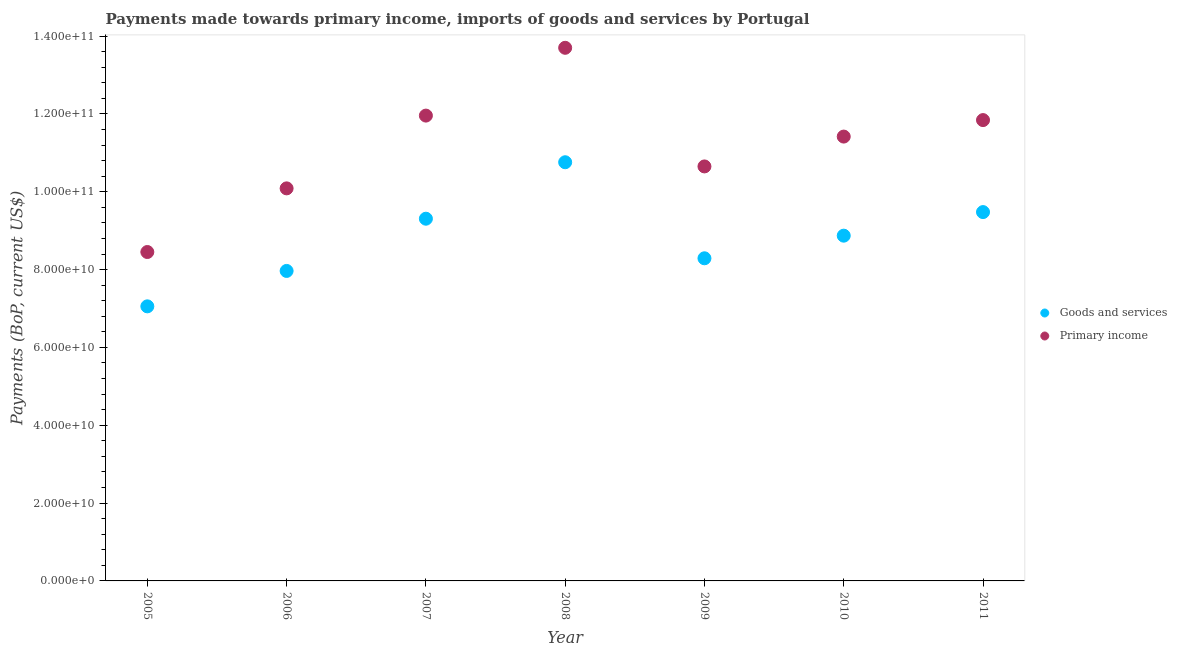What is the payments made towards primary income in 2005?
Provide a succinct answer. 8.45e+1. Across all years, what is the maximum payments made towards goods and services?
Your answer should be very brief. 1.08e+11. Across all years, what is the minimum payments made towards goods and services?
Offer a very short reply. 7.05e+1. In which year was the payments made towards goods and services maximum?
Provide a short and direct response. 2008. In which year was the payments made towards primary income minimum?
Keep it short and to the point. 2005. What is the total payments made towards primary income in the graph?
Offer a terse response. 7.81e+11. What is the difference between the payments made towards primary income in 2005 and that in 2009?
Ensure brevity in your answer.  -2.20e+1. What is the difference between the payments made towards primary income in 2007 and the payments made towards goods and services in 2009?
Your answer should be compact. 3.67e+1. What is the average payments made towards primary income per year?
Offer a very short reply. 1.12e+11. In the year 2010, what is the difference between the payments made towards primary income and payments made towards goods and services?
Give a very brief answer. 2.55e+1. In how many years, is the payments made towards goods and services greater than 128000000000 US$?
Your answer should be very brief. 0. What is the ratio of the payments made towards goods and services in 2009 to that in 2010?
Offer a very short reply. 0.93. Is the payments made towards goods and services in 2007 less than that in 2009?
Make the answer very short. No. Is the difference between the payments made towards goods and services in 2006 and 2008 greater than the difference between the payments made towards primary income in 2006 and 2008?
Ensure brevity in your answer.  Yes. What is the difference between the highest and the second highest payments made towards primary income?
Provide a short and direct response. 1.74e+1. What is the difference between the highest and the lowest payments made towards goods and services?
Make the answer very short. 3.70e+1. Is the sum of the payments made towards goods and services in 2010 and 2011 greater than the maximum payments made towards primary income across all years?
Ensure brevity in your answer.  Yes. Does the payments made towards primary income monotonically increase over the years?
Give a very brief answer. No. Is the payments made towards goods and services strictly greater than the payments made towards primary income over the years?
Your response must be concise. No. How many dotlines are there?
Provide a short and direct response. 2. Are the values on the major ticks of Y-axis written in scientific E-notation?
Ensure brevity in your answer.  Yes. Does the graph contain grids?
Ensure brevity in your answer.  No. How many legend labels are there?
Ensure brevity in your answer.  2. What is the title of the graph?
Your answer should be compact. Payments made towards primary income, imports of goods and services by Portugal. What is the label or title of the Y-axis?
Your response must be concise. Payments (BoP, current US$). What is the Payments (BoP, current US$) in Goods and services in 2005?
Make the answer very short. 7.05e+1. What is the Payments (BoP, current US$) of Primary income in 2005?
Ensure brevity in your answer.  8.45e+1. What is the Payments (BoP, current US$) of Goods and services in 2006?
Your response must be concise. 7.96e+1. What is the Payments (BoP, current US$) of Primary income in 2006?
Your response must be concise. 1.01e+11. What is the Payments (BoP, current US$) in Goods and services in 2007?
Provide a succinct answer. 9.31e+1. What is the Payments (BoP, current US$) in Primary income in 2007?
Offer a very short reply. 1.20e+11. What is the Payments (BoP, current US$) in Goods and services in 2008?
Your answer should be compact. 1.08e+11. What is the Payments (BoP, current US$) in Primary income in 2008?
Your answer should be very brief. 1.37e+11. What is the Payments (BoP, current US$) in Goods and services in 2009?
Keep it short and to the point. 8.29e+1. What is the Payments (BoP, current US$) of Primary income in 2009?
Ensure brevity in your answer.  1.07e+11. What is the Payments (BoP, current US$) in Goods and services in 2010?
Offer a terse response. 8.87e+1. What is the Payments (BoP, current US$) in Primary income in 2010?
Give a very brief answer. 1.14e+11. What is the Payments (BoP, current US$) of Goods and services in 2011?
Your answer should be very brief. 9.48e+1. What is the Payments (BoP, current US$) in Primary income in 2011?
Make the answer very short. 1.18e+11. Across all years, what is the maximum Payments (BoP, current US$) in Goods and services?
Ensure brevity in your answer.  1.08e+11. Across all years, what is the maximum Payments (BoP, current US$) in Primary income?
Keep it short and to the point. 1.37e+11. Across all years, what is the minimum Payments (BoP, current US$) of Goods and services?
Make the answer very short. 7.05e+1. Across all years, what is the minimum Payments (BoP, current US$) in Primary income?
Give a very brief answer. 8.45e+1. What is the total Payments (BoP, current US$) of Goods and services in the graph?
Offer a terse response. 6.17e+11. What is the total Payments (BoP, current US$) of Primary income in the graph?
Give a very brief answer. 7.81e+11. What is the difference between the Payments (BoP, current US$) in Goods and services in 2005 and that in 2006?
Make the answer very short. -9.10e+09. What is the difference between the Payments (BoP, current US$) of Primary income in 2005 and that in 2006?
Keep it short and to the point. -1.64e+1. What is the difference between the Payments (BoP, current US$) of Goods and services in 2005 and that in 2007?
Offer a terse response. -2.25e+1. What is the difference between the Payments (BoP, current US$) of Primary income in 2005 and that in 2007?
Provide a succinct answer. -3.50e+1. What is the difference between the Payments (BoP, current US$) of Goods and services in 2005 and that in 2008?
Make the answer very short. -3.70e+1. What is the difference between the Payments (BoP, current US$) in Primary income in 2005 and that in 2008?
Offer a terse response. -5.25e+1. What is the difference between the Payments (BoP, current US$) in Goods and services in 2005 and that in 2009?
Provide a short and direct response. -1.23e+1. What is the difference between the Payments (BoP, current US$) of Primary income in 2005 and that in 2009?
Your answer should be compact. -2.20e+1. What is the difference between the Payments (BoP, current US$) in Goods and services in 2005 and that in 2010?
Offer a very short reply. -1.82e+1. What is the difference between the Payments (BoP, current US$) in Primary income in 2005 and that in 2010?
Keep it short and to the point. -2.97e+1. What is the difference between the Payments (BoP, current US$) of Goods and services in 2005 and that in 2011?
Provide a succinct answer. -2.42e+1. What is the difference between the Payments (BoP, current US$) in Primary income in 2005 and that in 2011?
Give a very brief answer. -3.39e+1. What is the difference between the Payments (BoP, current US$) of Goods and services in 2006 and that in 2007?
Ensure brevity in your answer.  -1.34e+1. What is the difference between the Payments (BoP, current US$) in Primary income in 2006 and that in 2007?
Offer a terse response. -1.87e+1. What is the difference between the Payments (BoP, current US$) in Goods and services in 2006 and that in 2008?
Provide a short and direct response. -2.79e+1. What is the difference between the Payments (BoP, current US$) of Primary income in 2006 and that in 2008?
Your answer should be very brief. -3.61e+1. What is the difference between the Payments (BoP, current US$) of Goods and services in 2006 and that in 2009?
Provide a succinct answer. -3.25e+09. What is the difference between the Payments (BoP, current US$) in Primary income in 2006 and that in 2009?
Provide a succinct answer. -5.64e+09. What is the difference between the Payments (BoP, current US$) in Goods and services in 2006 and that in 2010?
Provide a succinct answer. -9.06e+09. What is the difference between the Payments (BoP, current US$) in Primary income in 2006 and that in 2010?
Make the answer very short. -1.33e+1. What is the difference between the Payments (BoP, current US$) of Goods and services in 2006 and that in 2011?
Ensure brevity in your answer.  -1.51e+1. What is the difference between the Payments (BoP, current US$) in Primary income in 2006 and that in 2011?
Make the answer very short. -1.75e+1. What is the difference between the Payments (BoP, current US$) of Goods and services in 2007 and that in 2008?
Offer a very short reply. -1.45e+1. What is the difference between the Payments (BoP, current US$) in Primary income in 2007 and that in 2008?
Your answer should be compact. -1.74e+1. What is the difference between the Payments (BoP, current US$) of Goods and services in 2007 and that in 2009?
Offer a very short reply. 1.02e+1. What is the difference between the Payments (BoP, current US$) of Primary income in 2007 and that in 2009?
Your answer should be very brief. 1.31e+1. What is the difference between the Payments (BoP, current US$) in Goods and services in 2007 and that in 2010?
Your response must be concise. 4.36e+09. What is the difference between the Payments (BoP, current US$) in Primary income in 2007 and that in 2010?
Offer a very short reply. 5.39e+09. What is the difference between the Payments (BoP, current US$) of Goods and services in 2007 and that in 2011?
Provide a succinct answer. -1.70e+09. What is the difference between the Payments (BoP, current US$) of Primary income in 2007 and that in 2011?
Offer a terse response. 1.15e+09. What is the difference between the Payments (BoP, current US$) in Goods and services in 2008 and that in 2009?
Your answer should be compact. 2.47e+1. What is the difference between the Payments (BoP, current US$) of Primary income in 2008 and that in 2009?
Offer a very short reply. 3.05e+1. What is the difference between the Payments (BoP, current US$) of Goods and services in 2008 and that in 2010?
Your response must be concise. 1.89e+1. What is the difference between the Payments (BoP, current US$) in Primary income in 2008 and that in 2010?
Offer a very short reply. 2.28e+1. What is the difference between the Payments (BoP, current US$) in Goods and services in 2008 and that in 2011?
Ensure brevity in your answer.  1.28e+1. What is the difference between the Payments (BoP, current US$) of Primary income in 2008 and that in 2011?
Offer a terse response. 1.86e+1. What is the difference between the Payments (BoP, current US$) of Goods and services in 2009 and that in 2010?
Your answer should be very brief. -5.81e+09. What is the difference between the Payments (BoP, current US$) of Primary income in 2009 and that in 2010?
Your response must be concise. -7.67e+09. What is the difference between the Payments (BoP, current US$) in Goods and services in 2009 and that in 2011?
Your answer should be very brief. -1.19e+1. What is the difference between the Payments (BoP, current US$) in Primary income in 2009 and that in 2011?
Keep it short and to the point. -1.19e+1. What is the difference between the Payments (BoP, current US$) in Goods and services in 2010 and that in 2011?
Give a very brief answer. -6.06e+09. What is the difference between the Payments (BoP, current US$) of Primary income in 2010 and that in 2011?
Your response must be concise. -4.24e+09. What is the difference between the Payments (BoP, current US$) in Goods and services in 2005 and the Payments (BoP, current US$) in Primary income in 2006?
Give a very brief answer. -3.03e+1. What is the difference between the Payments (BoP, current US$) of Goods and services in 2005 and the Payments (BoP, current US$) of Primary income in 2007?
Keep it short and to the point. -4.90e+1. What is the difference between the Payments (BoP, current US$) in Goods and services in 2005 and the Payments (BoP, current US$) in Primary income in 2008?
Give a very brief answer. -6.64e+1. What is the difference between the Payments (BoP, current US$) of Goods and services in 2005 and the Payments (BoP, current US$) of Primary income in 2009?
Your answer should be compact. -3.60e+1. What is the difference between the Payments (BoP, current US$) of Goods and services in 2005 and the Payments (BoP, current US$) of Primary income in 2010?
Ensure brevity in your answer.  -4.36e+1. What is the difference between the Payments (BoP, current US$) of Goods and services in 2005 and the Payments (BoP, current US$) of Primary income in 2011?
Offer a very short reply. -4.79e+1. What is the difference between the Payments (BoP, current US$) of Goods and services in 2006 and the Payments (BoP, current US$) of Primary income in 2007?
Offer a very short reply. -3.99e+1. What is the difference between the Payments (BoP, current US$) of Goods and services in 2006 and the Payments (BoP, current US$) of Primary income in 2008?
Your answer should be compact. -5.73e+1. What is the difference between the Payments (BoP, current US$) of Goods and services in 2006 and the Payments (BoP, current US$) of Primary income in 2009?
Your answer should be very brief. -2.69e+1. What is the difference between the Payments (BoP, current US$) of Goods and services in 2006 and the Payments (BoP, current US$) of Primary income in 2010?
Make the answer very short. -3.45e+1. What is the difference between the Payments (BoP, current US$) of Goods and services in 2006 and the Payments (BoP, current US$) of Primary income in 2011?
Your answer should be very brief. -3.88e+1. What is the difference between the Payments (BoP, current US$) of Goods and services in 2007 and the Payments (BoP, current US$) of Primary income in 2008?
Your response must be concise. -4.39e+1. What is the difference between the Payments (BoP, current US$) of Goods and services in 2007 and the Payments (BoP, current US$) of Primary income in 2009?
Your response must be concise. -1.34e+1. What is the difference between the Payments (BoP, current US$) of Goods and services in 2007 and the Payments (BoP, current US$) of Primary income in 2010?
Provide a short and direct response. -2.11e+1. What is the difference between the Payments (BoP, current US$) of Goods and services in 2007 and the Payments (BoP, current US$) of Primary income in 2011?
Keep it short and to the point. -2.53e+1. What is the difference between the Payments (BoP, current US$) in Goods and services in 2008 and the Payments (BoP, current US$) in Primary income in 2009?
Your answer should be very brief. 1.07e+09. What is the difference between the Payments (BoP, current US$) in Goods and services in 2008 and the Payments (BoP, current US$) in Primary income in 2010?
Provide a succinct answer. -6.60e+09. What is the difference between the Payments (BoP, current US$) in Goods and services in 2008 and the Payments (BoP, current US$) in Primary income in 2011?
Your answer should be compact. -1.08e+1. What is the difference between the Payments (BoP, current US$) in Goods and services in 2009 and the Payments (BoP, current US$) in Primary income in 2010?
Provide a short and direct response. -3.13e+1. What is the difference between the Payments (BoP, current US$) in Goods and services in 2009 and the Payments (BoP, current US$) in Primary income in 2011?
Provide a succinct answer. -3.55e+1. What is the difference between the Payments (BoP, current US$) in Goods and services in 2010 and the Payments (BoP, current US$) in Primary income in 2011?
Your answer should be very brief. -2.97e+1. What is the average Payments (BoP, current US$) in Goods and services per year?
Your answer should be compact. 8.82e+1. What is the average Payments (BoP, current US$) in Primary income per year?
Make the answer very short. 1.12e+11. In the year 2005, what is the difference between the Payments (BoP, current US$) in Goods and services and Payments (BoP, current US$) in Primary income?
Your answer should be compact. -1.40e+1. In the year 2006, what is the difference between the Payments (BoP, current US$) of Goods and services and Payments (BoP, current US$) of Primary income?
Your response must be concise. -2.12e+1. In the year 2007, what is the difference between the Payments (BoP, current US$) of Goods and services and Payments (BoP, current US$) of Primary income?
Provide a succinct answer. -2.65e+1. In the year 2008, what is the difference between the Payments (BoP, current US$) in Goods and services and Payments (BoP, current US$) in Primary income?
Make the answer very short. -2.94e+1. In the year 2009, what is the difference between the Payments (BoP, current US$) of Goods and services and Payments (BoP, current US$) of Primary income?
Keep it short and to the point. -2.36e+1. In the year 2010, what is the difference between the Payments (BoP, current US$) in Goods and services and Payments (BoP, current US$) in Primary income?
Provide a short and direct response. -2.55e+1. In the year 2011, what is the difference between the Payments (BoP, current US$) of Goods and services and Payments (BoP, current US$) of Primary income?
Your response must be concise. -2.36e+1. What is the ratio of the Payments (BoP, current US$) of Goods and services in 2005 to that in 2006?
Offer a terse response. 0.89. What is the ratio of the Payments (BoP, current US$) of Primary income in 2005 to that in 2006?
Provide a short and direct response. 0.84. What is the ratio of the Payments (BoP, current US$) of Goods and services in 2005 to that in 2007?
Keep it short and to the point. 0.76. What is the ratio of the Payments (BoP, current US$) in Primary income in 2005 to that in 2007?
Provide a succinct answer. 0.71. What is the ratio of the Payments (BoP, current US$) in Goods and services in 2005 to that in 2008?
Make the answer very short. 0.66. What is the ratio of the Payments (BoP, current US$) of Primary income in 2005 to that in 2008?
Your answer should be compact. 0.62. What is the ratio of the Payments (BoP, current US$) in Goods and services in 2005 to that in 2009?
Keep it short and to the point. 0.85. What is the ratio of the Payments (BoP, current US$) in Primary income in 2005 to that in 2009?
Make the answer very short. 0.79. What is the ratio of the Payments (BoP, current US$) of Goods and services in 2005 to that in 2010?
Give a very brief answer. 0.8. What is the ratio of the Payments (BoP, current US$) in Primary income in 2005 to that in 2010?
Offer a terse response. 0.74. What is the ratio of the Payments (BoP, current US$) of Goods and services in 2005 to that in 2011?
Your answer should be very brief. 0.74. What is the ratio of the Payments (BoP, current US$) of Primary income in 2005 to that in 2011?
Keep it short and to the point. 0.71. What is the ratio of the Payments (BoP, current US$) of Goods and services in 2006 to that in 2007?
Your response must be concise. 0.86. What is the ratio of the Payments (BoP, current US$) of Primary income in 2006 to that in 2007?
Offer a terse response. 0.84. What is the ratio of the Payments (BoP, current US$) of Goods and services in 2006 to that in 2008?
Ensure brevity in your answer.  0.74. What is the ratio of the Payments (BoP, current US$) in Primary income in 2006 to that in 2008?
Ensure brevity in your answer.  0.74. What is the ratio of the Payments (BoP, current US$) in Goods and services in 2006 to that in 2009?
Offer a very short reply. 0.96. What is the ratio of the Payments (BoP, current US$) of Primary income in 2006 to that in 2009?
Offer a very short reply. 0.95. What is the ratio of the Payments (BoP, current US$) in Goods and services in 2006 to that in 2010?
Provide a short and direct response. 0.9. What is the ratio of the Payments (BoP, current US$) of Primary income in 2006 to that in 2010?
Your answer should be compact. 0.88. What is the ratio of the Payments (BoP, current US$) of Goods and services in 2006 to that in 2011?
Offer a very short reply. 0.84. What is the ratio of the Payments (BoP, current US$) in Primary income in 2006 to that in 2011?
Provide a short and direct response. 0.85. What is the ratio of the Payments (BoP, current US$) in Goods and services in 2007 to that in 2008?
Give a very brief answer. 0.87. What is the ratio of the Payments (BoP, current US$) of Primary income in 2007 to that in 2008?
Make the answer very short. 0.87. What is the ratio of the Payments (BoP, current US$) of Goods and services in 2007 to that in 2009?
Offer a terse response. 1.12. What is the ratio of the Payments (BoP, current US$) in Primary income in 2007 to that in 2009?
Give a very brief answer. 1.12. What is the ratio of the Payments (BoP, current US$) of Goods and services in 2007 to that in 2010?
Your answer should be compact. 1.05. What is the ratio of the Payments (BoP, current US$) of Primary income in 2007 to that in 2010?
Keep it short and to the point. 1.05. What is the ratio of the Payments (BoP, current US$) of Goods and services in 2007 to that in 2011?
Your answer should be very brief. 0.98. What is the ratio of the Payments (BoP, current US$) in Primary income in 2007 to that in 2011?
Your answer should be compact. 1.01. What is the ratio of the Payments (BoP, current US$) of Goods and services in 2008 to that in 2009?
Offer a very short reply. 1.3. What is the ratio of the Payments (BoP, current US$) of Primary income in 2008 to that in 2009?
Provide a short and direct response. 1.29. What is the ratio of the Payments (BoP, current US$) of Goods and services in 2008 to that in 2010?
Provide a short and direct response. 1.21. What is the ratio of the Payments (BoP, current US$) in Primary income in 2008 to that in 2010?
Ensure brevity in your answer.  1.2. What is the ratio of the Payments (BoP, current US$) of Goods and services in 2008 to that in 2011?
Your response must be concise. 1.14. What is the ratio of the Payments (BoP, current US$) in Primary income in 2008 to that in 2011?
Offer a very short reply. 1.16. What is the ratio of the Payments (BoP, current US$) in Goods and services in 2009 to that in 2010?
Ensure brevity in your answer.  0.93. What is the ratio of the Payments (BoP, current US$) in Primary income in 2009 to that in 2010?
Offer a terse response. 0.93. What is the ratio of the Payments (BoP, current US$) of Goods and services in 2009 to that in 2011?
Your answer should be compact. 0.87. What is the ratio of the Payments (BoP, current US$) of Primary income in 2009 to that in 2011?
Your answer should be very brief. 0.9. What is the ratio of the Payments (BoP, current US$) in Goods and services in 2010 to that in 2011?
Offer a very short reply. 0.94. What is the ratio of the Payments (BoP, current US$) in Primary income in 2010 to that in 2011?
Keep it short and to the point. 0.96. What is the difference between the highest and the second highest Payments (BoP, current US$) of Goods and services?
Keep it short and to the point. 1.28e+1. What is the difference between the highest and the second highest Payments (BoP, current US$) in Primary income?
Your answer should be compact. 1.74e+1. What is the difference between the highest and the lowest Payments (BoP, current US$) of Goods and services?
Offer a very short reply. 3.70e+1. What is the difference between the highest and the lowest Payments (BoP, current US$) in Primary income?
Give a very brief answer. 5.25e+1. 